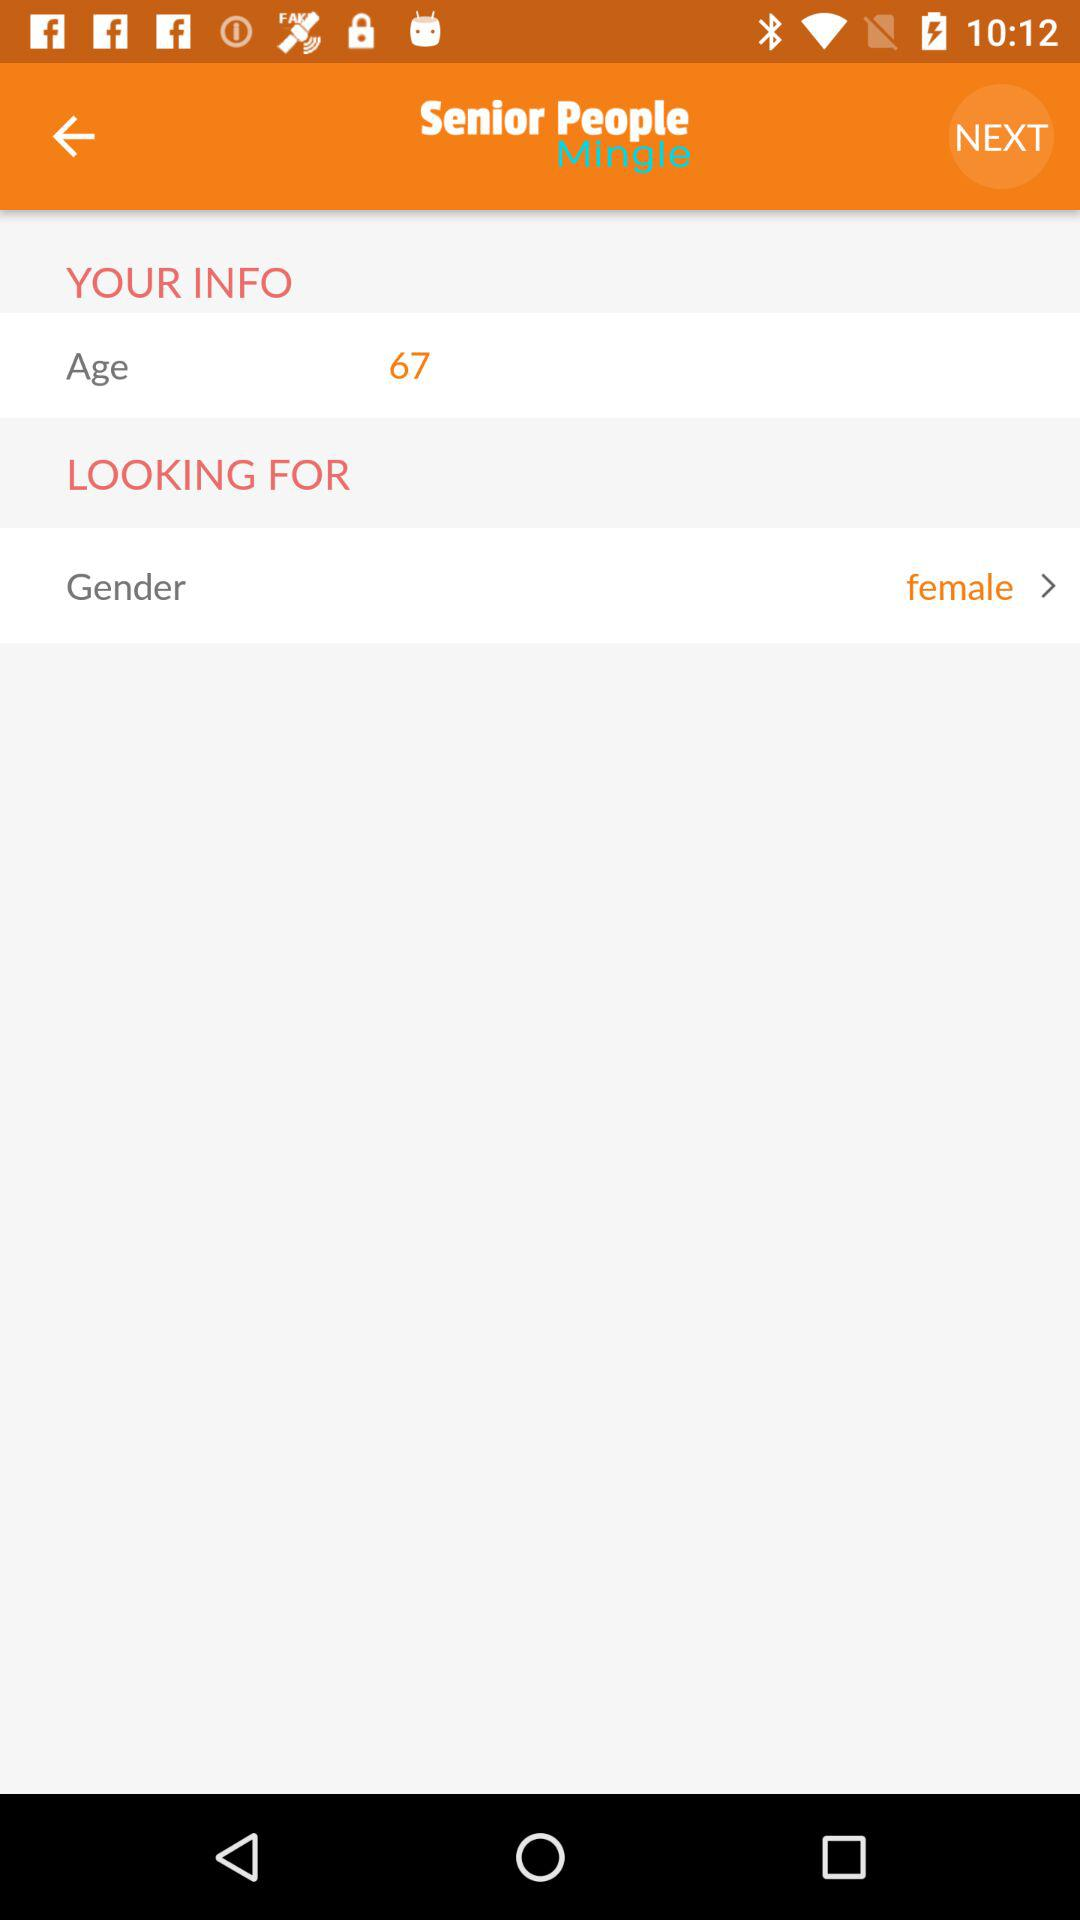What is the app name? The app name is "Senior People Mingle". 